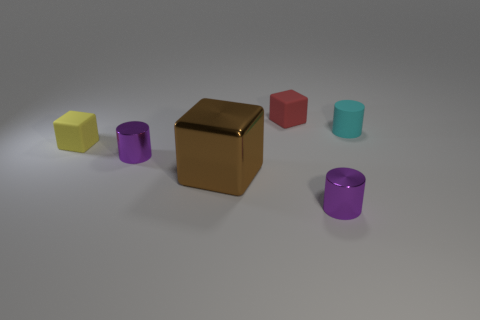Subtract 1 cubes. How many cubes are left? 2 Add 4 yellow objects. How many objects exist? 10 Add 5 cyan objects. How many cyan objects are left? 6 Add 5 tiny green matte balls. How many tiny green matte balls exist? 5 Subtract 0 blue spheres. How many objects are left? 6 Subtract all big yellow spheres. Subtract all purple things. How many objects are left? 4 